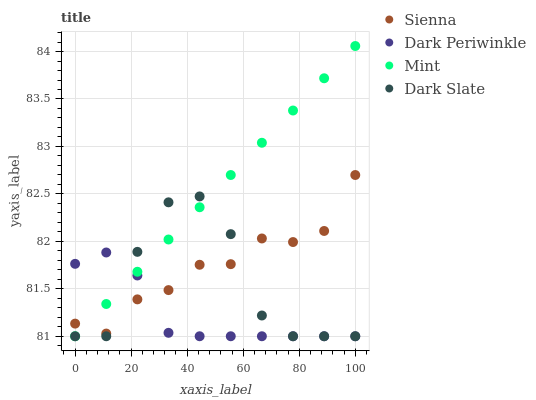Does Dark Periwinkle have the minimum area under the curve?
Answer yes or no. Yes. Does Mint have the maximum area under the curve?
Answer yes or no. Yes. Does Dark Slate have the minimum area under the curve?
Answer yes or no. No. Does Dark Slate have the maximum area under the curve?
Answer yes or no. No. Is Mint the smoothest?
Answer yes or no. Yes. Is Dark Slate the roughest?
Answer yes or no. Yes. Is Dark Slate the smoothest?
Answer yes or no. No. Is Mint the roughest?
Answer yes or no. No. Does Dark Slate have the lowest value?
Answer yes or no. Yes. Does Mint have the highest value?
Answer yes or no. Yes. Does Dark Slate have the highest value?
Answer yes or no. No. Does Mint intersect Dark Periwinkle?
Answer yes or no. Yes. Is Mint less than Dark Periwinkle?
Answer yes or no. No. Is Mint greater than Dark Periwinkle?
Answer yes or no. No. 